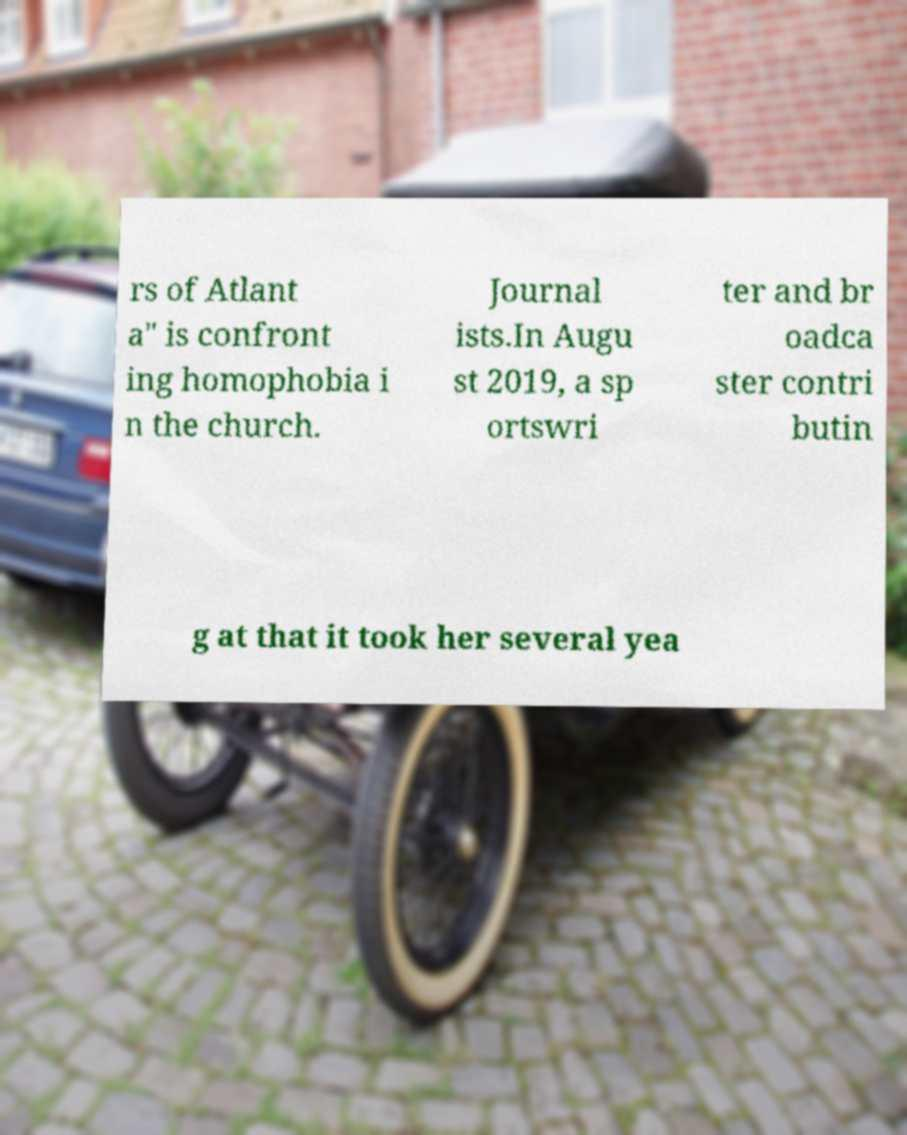What messages or text are displayed in this image? I need them in a readable, typed format. rs of Atlant a" is confront ing homophobia i n the church. Journal ists.In Augu st 2019, a sp ortswri ter and br oadca ster contri butin g at that it took her several yea 